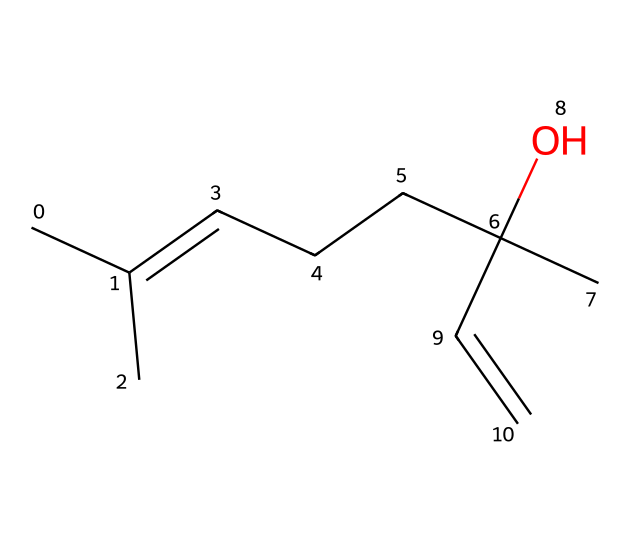What is the molecular formula of linalool? To find the molecular formula, we can determine the number of each atom present in the SMILES representation. The structure denotes: 10 carbon (C) atoms, 18 hydrogen (H) atoms, and 1 oxygen (O) atom, resulting in a molecular formula of C10H18O.
Answer: C10H18O How many rings are present in the structure? The SMILES representation does not show any cyclic structures, indicating there are zero rings in the molecule, which can be inferred from the lack of numbers indicating ring closures.
Answer: 0 What kind of functional group is represented by the presence of the hydroxyl group in linalool? The presence of the -OH functional group identifies this as an alcohol. Alcohols are characterized by the hydroxyl group directly attached to a carbon atom.
Answer: alcohol What is the degree of unsaturation for linalool? The degree of unsaturation can be calculated based on the number of π bonds and rings. In this structure, there is one double bond and no rings, leading to a total degree of unsaturation of 1. This is a critical aspect as it influences the chemical reactivity and properties of linalool.
Answer: 1 What is the significance of the double bond in linalool? The double bond contributes to the unsaturation of the molecule, which can increase the volatility and alter the fragrance profile of the essential oil. A double bond may also affect the overall stability and reactivity of the molecule.
Answer: fragrance profile What type of chemical compound is linalool classified as? Linalool is classified as a terpene, which are common components in essential oils, often contributing to their aroma and therapeutic properties. The structure's carbon backbone is indicative of terpene characteristics, which typically have multiple carbons arranged in a specific configuration.
Answer: terpene 